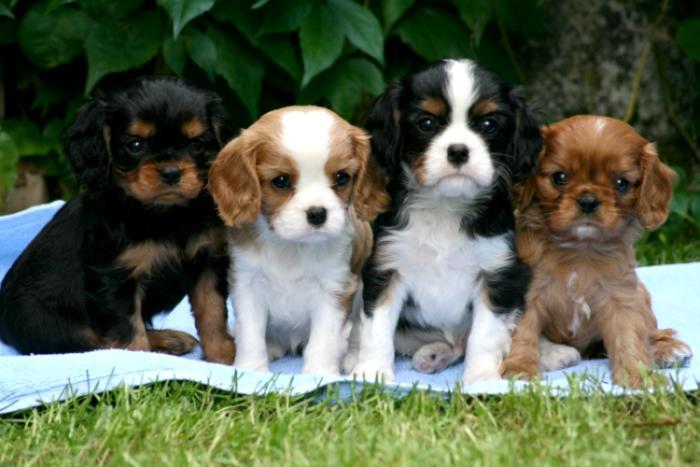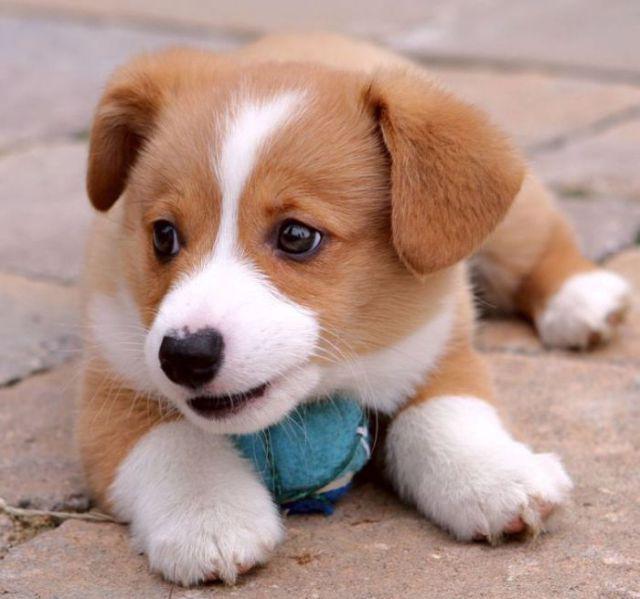The first image is the image on the left, the second image is the image on the right. Assess this claim about the two images: "There are two dogs with black ears and two dogs with brown ears sitting in a row in the image on the left.". Correct or not? Answer yes or no. Yes. The first image is the image on the left, the second image is the image on the right. Analyze the images presented: Is the assertion "There are 4 or more puppies being displayed on a cushion." valid? Answer yes or no. No. 